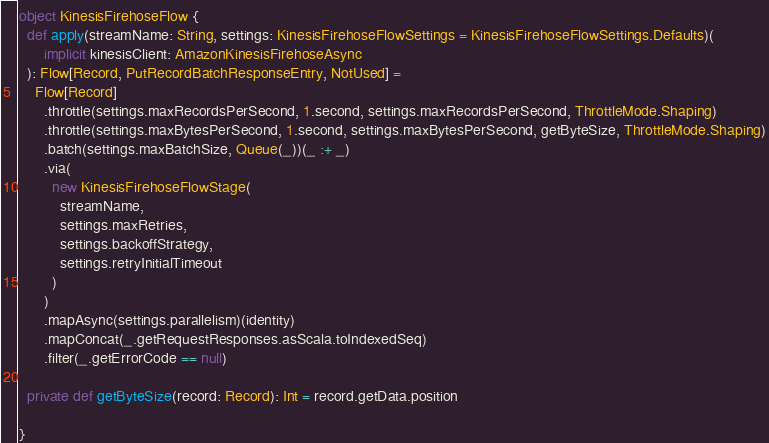Convert code to text. <code><loc_0><loc_0><loc_500><loc_500><_Scala_>object KinesisFirehoseFlow {
  def apply(streamName: String, settings: KinesisFirehoseFlowSettings = KinesisFirehoseFlowSettings.Defaults)(
      implicit kinesisClient: AmazonKinesisFirehoseAsync
  ): Flow[Record, PutRecordBatchResponseEntry, NotUsed] =
    Flow[Record]
      .throttle(settings.maxRecordsPerSecond, 1.second, settings.maxRecordsPerSecond, ThrottleMode.Shaping)
      .throttle(settings.maxBytesPerSecond, 1.second, settings.maxBytesPerSecond, getByteSize, ThrottleMode.Shaping)
      .batch(settings.maxBatchSize, Queue(_))(_ :+ _)
      .via(
        new KinesisFirehoseFlowStage(
          streamName,
          settings.maxRetries,
          settings.backoffStrategy,
          settings.retryInitialTimeout
        )
      )
      .mapAsync(settings.parallelism)(identity)
      .mapConcat(_.getRequestResponses.asScala.toIndexedSeq)
      .filter(_.getErrorCode == null)

  private def getByteSize(record: Record): Int = record.getData.position

}
</code> 